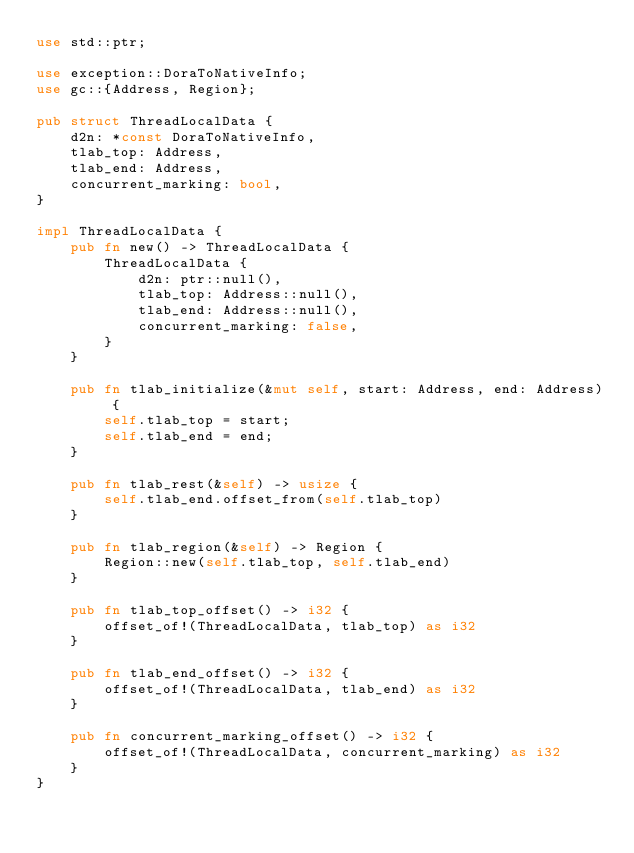<code> <loc_0><loc_0><loc_500><loc_500><_Rust_>use std::ptr;

use exception::DoraToNativeInfo;
use gc::{Address, Region};

pub struct ThreadLocalData {
    d2n: *const DoraToNativeInfo,
    tlab_top: Address,
    tlab_end: Address,
    concurrent_marking: bool,
}

impl ThreadLocalData {
    pub fn new() -> ThreadLocalData {
        ThreadLocalData {
            d2n: ptr::null(),
            tlab_top: Address::null(),
            tlab_end: Address::null(),
            concurrent_marking: false,
        }
    }

    pub fn tlab_initialize(&mut self, start: Address, end: Address) {
        self.tlab_top = start;
        self.tlab_end = end;
    }

    pub fn tlab_rest(&self) -> usize {
        self.tlab_end.offset_from(self.tlab_top)
    }

    pub fn tlab_region(&self) -> Region {
        Region::new(self.tlab_top, self.tlab_end)
    }

    pub fn tlab_top_offset() -> i32 {
        offset_of!(ThreadLocalData, tlab_top) as i32
    }

    pub fn tlab_end_offset() -> i32 {
        offset_of!(ThreadLocalData, tlab_end) as i32
    }

    pub fn concurrent_marking_offset() -> i32 {
        offset_of!(ThreadLocalData, concurrent_marking) as i32
    }
}
</code> 